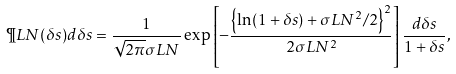Convert formula to latex. <formula><loc_0><loc_0><loc_500><loc_500>\P L N ( \delta s ) d \delta s = \frac { 1 } { \sqrt { 2 \pi } \sigma L N } \exp \left [ - \frac { \left \{ \ln ( 1 + \delta s ) + \sigma L N ^ { 2 } / 2 \right \} ^ { 2 } } { 2 \sigma L N ^ { 2 } } \right ] \frac { d \delta s } { 1 + \delta s } ,</formula> 